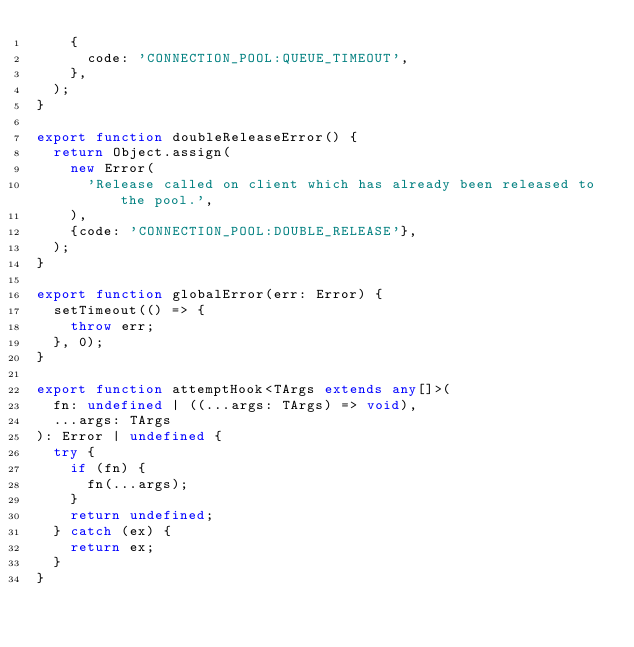<code> <loc_0><loc_0><loc_500><loc_500><_TypeScript_>    {
      code: 'CONNECTION_POOL:QUEUE_TIMEOUT',
    },
  );
}

export function doubleReleaseError() {
  return Object.assign(
    new Error(
      'Release called on client which has already been released to the pool.',
    ),
    {code: 'CONNECTION_POOL:DOUBLE_RELEASE'},
  );
}

export function globalError(err: Error) {
  setTimeout(() => {
    throw err;
  }, 0);
}

export function attemptHook<TArgs extends any[]>(
  fn: undefined | ((...args: TArgs) => void),
  ...args: TArgs
): Error | undefined {
  try {
    if (fn) {
      fn(...args);
    }
    return undefined;
  } catch (ex) {
    return ex;
  }
}
</code> 